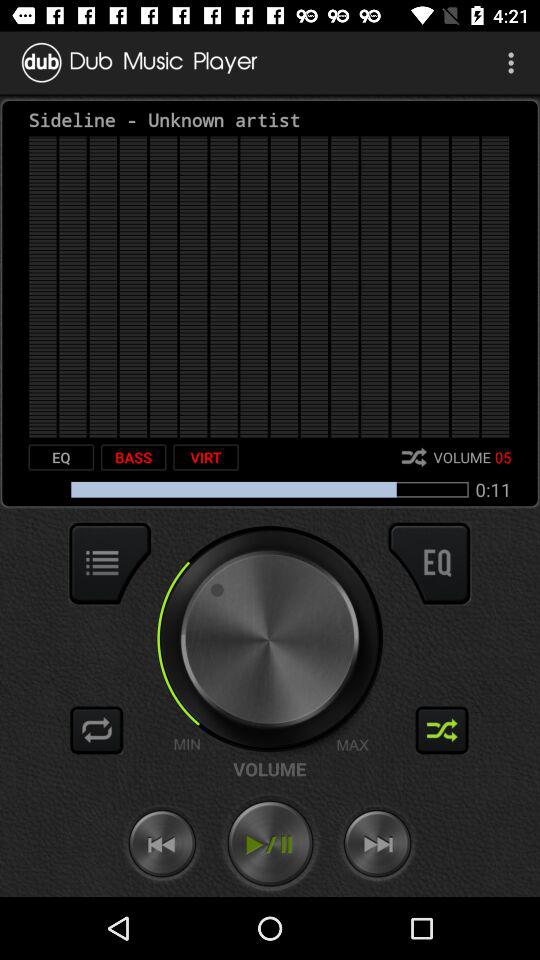What is the name of the music player?
When the provided information is insufficient, respond with <no answer>. <no answer> 